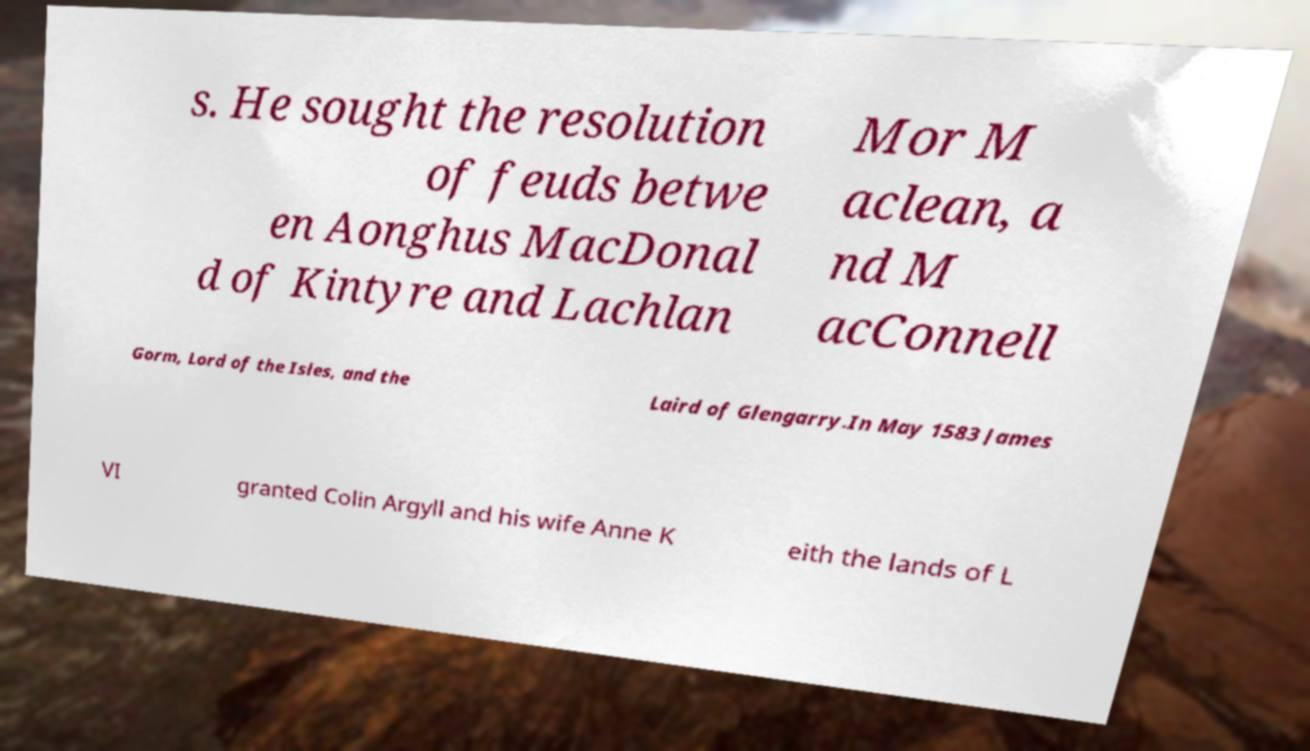There's text embedded in this image that I need extracted. Can you transcribe it verbatim? s. He sought the resolution of feuds betwe en Aonghus MacDonal d of Kintyre and Lachlan Mor M aclean, a nd M acConnell Gorm, Lord of the Isles, and the Laird of Glengarry.In May 1583 James VI granted Colin Argyll and his wife Anne K eith the lands of L 